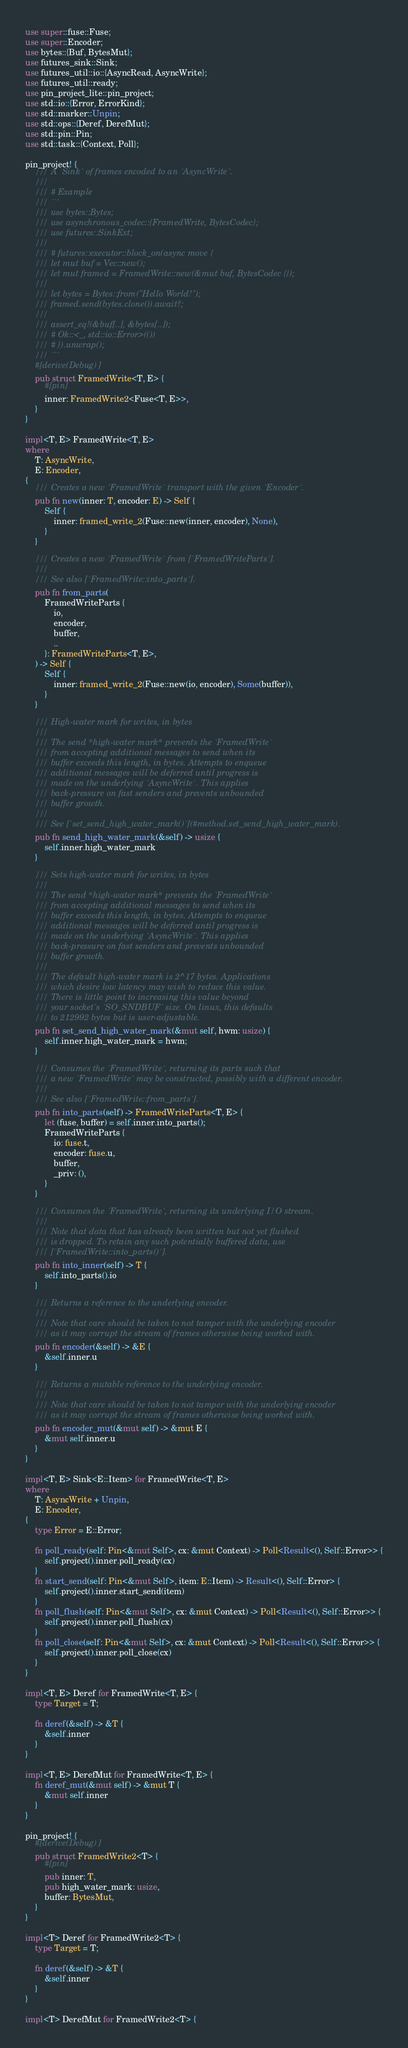Convert code to text. <code><loc_0><loc_0><loc_500><loc_500><_Rust_>use super::fuse::Fuse;
use super::Encoder;
use bytes::{Buf, BytesMut};
use futures_sink::Sink;
use futures_util::io::{AsyncRead, AsyncWrite};
use futures_util::ready;
use pin_project_lite::pin_project;
use std::io::{Error, ErrorKind};
use std::marker::Unpin;
use std::ops::{Deref, DerefMut};
use std::pin::Pin;
use std::task::{Context, Poll};

pin_project! {
    /// A `Sink` of frames encoded to an `AsyncWrite`.
    ///
    /// # Example
    /// ```
    /// use bytes::Bytes;
    /// use asynchronous_codec::{FramedWrite, BytesCodec};
    /// use futures::SinkExt;
    ///
    /// # futures::executor::block_on(async move {
    /// let mut buf = Vec::new();
    /// let mut framed = FramedWrite::new(&mut buf, BytesCodec {});
    ///
    /// let bytes = Bytes::from("Hello World!");
    /// framed.send(bytes.clone()).await?;
    ///
    /// assert_eq!(&buf[..], &bytes[..]);
    /// # Ok::<_, std::io::Error>(())
    /// # }).unwrap();
    /// ```
    #[derive(Debug)]
    pub struct FramedWrite<T, E> {
        #[pin]
        inner: FramedWrite2<Fuse<T, E>>,
    }
}

impl<T, E> FramedWrite<T, E>
where
    T: AsyncWrite,
    E: Encoder,
{
    /// Creates a new `FramedWrite` transport with the given `Encoder`.
    pub fn new(inner: T, encoder: E) -> Self {
        Self {
            inner: framed_write_2(Fuse::new(inner, encoder), None),
        }
    }

    /// Creates a new `FramedWrite` from [`FramedWriteParts`].
    ///
    /// See also [`FramedWrite::into_parts`].
    pub fn from_parts(
        FramedWriteParts {
            io,
            encoder,
            buffer,
            ..
        }: FramedWriteParts<T, E>,
    ) -> Self {
        Self {
            inner: framed_write_2(Fuse::new(io, encoder), Some(buffer)),
        }
    }

    /// High-water mark for writes, in bytes
    ///
    /// The send *high-water mark* prevents the `FramedWrite`
    /// from accepting additional messages to send when its
    /// buffer exceeds this length, in bytes. Attempts to enqueue
    /// additional messages will be deferred until progress is
    /// made on the underlying `AsyncWrite`. This applies
    /// back-pressure on fast senders and prevents unbounded
    /// buffer growth.
    ///
    /// See [`set_send_high_water_mark()`](#method.set_send_high_water_mark).
    pub fn send_high_water_mark(&self) -> usize {
        self.inner.high_water_mark
    }

    /// Sets high-water mark for writes, in bytes
    ///
    /// The send *high-water mark* prevents the `FramedWrite`
    /// from accepting additional messages to send when its
    /// buffer exceeds this length, in bytes. Attempts to enqueue
    /// additional messages will be deferred until progress is
    /// made on the underlying `AsyncWrite`. This applies
    /// back-pressure on fast senders and prevents unbounded
    /// buffer growth.
    ///
    /// The default high-water mark is 2^17 bytes. Applications
    /// which desire low latency may wish to reduce this value.
    /// There is little point to increasing this value beyond
    /// your socket's `SO_SNDBUF` size. On linux, this defaults
    /// to 212992 bytes but is user-adjustable.
    pub fn set_send_high_water_mark(&mut self, hwm: usize) {
        self.inner.high_water_mark = hwm;
    }

    /// Consumes the `FramedWrite`, returning its parts such that
    /// a new `FramedWrite` may be constructed, possibly with a different encoder.
    ///
    /// See also [`FramedWrite::from_parts`].
    pub fn into_parts(self) -> FramedWriteParts<T, E> {
        let (fuse, buffer) = self.inner.into_parts();
        FramedWriteParts {
            io: fuse.t,
            encoder: fuse.u,
            buffer,
            _priv: (),
        }
    }

    /// Consumes the `FramedWrite`, returning its underlying I/O stream.
    ///
    /// Note that data that has already been written but not yet flushed
    /// is dropped. To retain any such potentially buffered data, use
    /// [`FramedWrite::into_parts()`].
    pub fn into_inner(self) -> T {
        self.into_parts().io
    }

    /// Returns a reference to the underlying encoder.
    ///
    /// Note that care should be taken to not tamper with the underlying encoder
    /// as it may corrupt the stream of frames otherwise being worked with.
    pub fn encoder(&self) -> &E {
        &self.inner.u
    }

    /// Returns a mutable reference to the underlying encoder.
    ///
    /// Note that care should be taken to not tamper with the underlying encoder
    /// as it may corrupt the stream of frames otherwise being worked with.
    pub fn encoder_mut(&mut self) -> &mut E {
        &mut self.inner.u
    }
}

impl<T, E> Sink<E::Item> for FramedWrite<T, E>
where
    T: AsyncWrite + Unpin,
    E: Encoder,
{
    type Error = E::Error;

    fn poll_ready(self: Pin<&mut Self>, cx: &mut Context) -> Poll<Result<(), Self::Error>> {
        self.project().inner.poll_ready(cx)
    }
    fn start_send(self: Pin<&mut Self>, item: E::Item) -> Result<(), Self::Error> {
        self.project().inner.start_send(item)
    }
    fn poll_flush(self: Pin<&mut Self>, cx: &mut Context) -> Poll<Result<(), Self::Error>> {
        self.project().inner.poll_flush(cx)
    }
    fn poll_close(self: Pin<&mut Self>, cx: &mut Context) -> Poll<Result<(), Self::Error>> {
        self.project().inner.poll_close(cx)
    }
}

impl<T, E> Deref for FramedWrite<T, E> {
    type Target = T;

    fn deref(&self) -> &T {
        &self.inner
    }
}

impl<T, E> DerefMut for FramedWrite<T, E> {
    fn deref_mut(&mut self) -> &mut T {
        &mut self.inner
    }
}

pin_project! {
    #[derive(Debug)]
    pub struct FramedWrite2<T> {
        #[pin]
        pub inner: T,
        pub high_water_mark: usize,
        buffer: BytesMut,
    }
}

impl<T> Deref for FramedWrite2<T> {
    type Target = T;

    fn deref(&self) -> &T {
        &self.inner
    }
}

impl<T> DerefMut for FramedWrite2<T> {</code> 